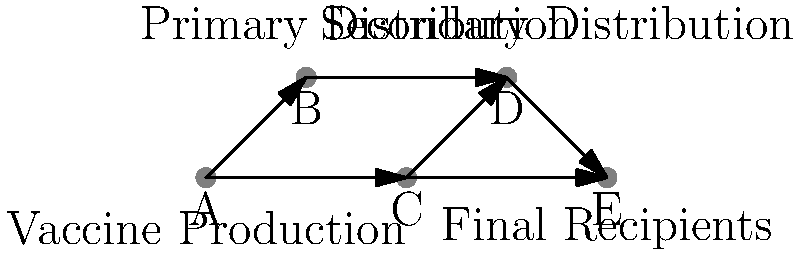In the vaccine distribution network shown above, which country serves as both a primary and secondary distribution hub, potentially playing a crucial role in regional vaccine accessibility? To answer this question, we need to analyze the flowchart of the vaccine distribution network:

1. Country A is the vaccine production center, as it has outgoing arrows but no incoming ones.
2. Countries B and C receive vaccines directly from A, making them primary distribution hubs.
3. Country D receives vaccines from both B and C, indicating it's a secondary distribution hub.
4. Country E receives vaccines from both C and D, suggesting it's a final recipient.
5. Country C is unique in this network because:
   a) It receives vaccines directly from the production center (A), making it a primary distribution hub.
   b) It also distributes vaccines to both a secondary hub (D) and a final recipient (E), functioning as a secondary distribution hub.

Therefore, Country C serves as both a primary and secondary distribution hub, potentially playing a crucial role in regional vaccine accessibility by bridging the gap between production and final distribution.
Answer: Country C 